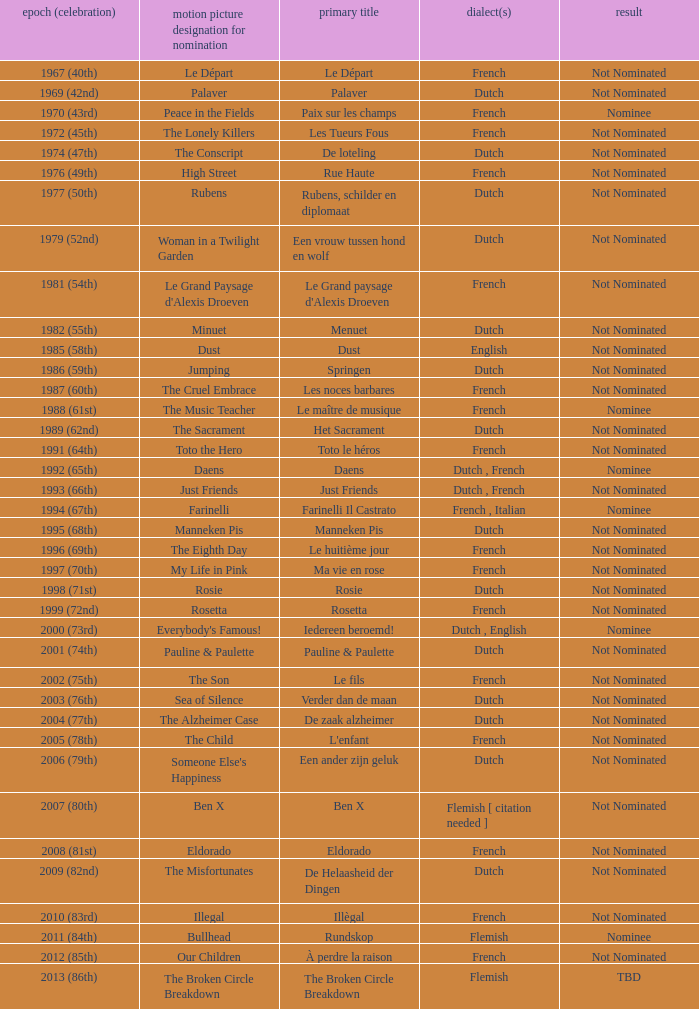What is the language of the film Rosie? Dutch. 